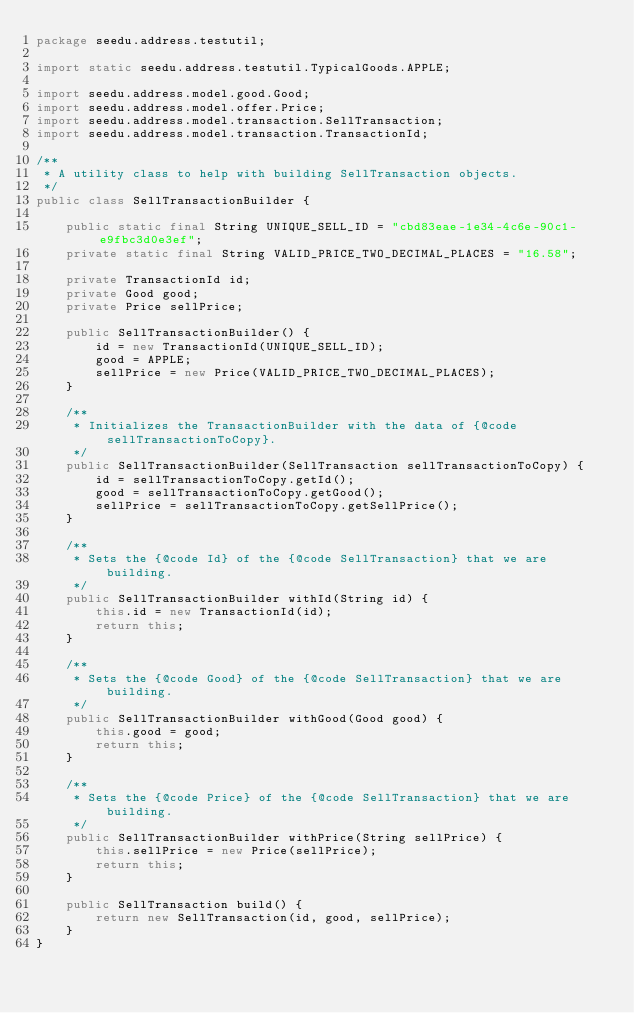Convert code to text. <code><loc_0><loc_0><loc_500><loc_500><_Java_>package seedu.address.testutil;

import static seedu.address.testutil.TypicalGoods.APPLE;

import seedu.address.model.good.Good;
import seedu.address.model.offer.Price;
import seedu.address.model.transaction.SellTransaction;
import seedu.address.model.transaction.TransactionId;

/**
 * A utility class to help with building SellTransaction objects.
 */
public class SellTransactionBuilder {

    public static final String UNIQUE_SELL_ID = "cbd83eae-1e34-4c6e-90c1-e9fbc3d0e3ef";
    private static final String VALID_PRICE_TWO_DECIMAL_PLACES = "16.58";

    private TransactionId id;
    private Good good;
    private Price sellPrice;

    public SellTransactionBuilder() {
        id = new TransactionId(UNIQUE_SELL_ID);
        good = APPLE;
        sellPrice = new Price(VALID_PRICE_TWO_DECIMAL_PLACES);
    }

    /**
     * Initializes the TransactionBuilder with the data of {@code sellTransactionToCopy}.
     */
    public SellTransactionBuilder(SellTransaction sellTransactionToCopy) {
        id = sellTransactionToCopy.getId();
        good = sellTransactionToCopy.getGood();
        sellPrice = sellTransactionToCopy.getSellPrice();
    }

    /**
     * Sets the {@code Id} of the {@code SellTransaction} that we are building.
     */
    public SellTransactionBuilder withId(String id) {
        this.id = new TransactionId(id);
        return this;
    }

    /**
     * Sets the {@code Good} of the {@code SellTransaction} that we are building.
     */
    public SellTransactionBuilder withGood(Good good) {
        this.good = good;
        return this;
    }

    /**
     * Sets the {@code Price} of the {@code SellTransaction} that we are building.
     */
    public SellTransactionBuilder withPrice(String sellPrice) {
        this.sellPrice = new Price(sellPrice);
        return this;
    }

    public SellTransaction build() {
        return new SellTransaction(id, good, sellPrice);
    }
}
</code> 